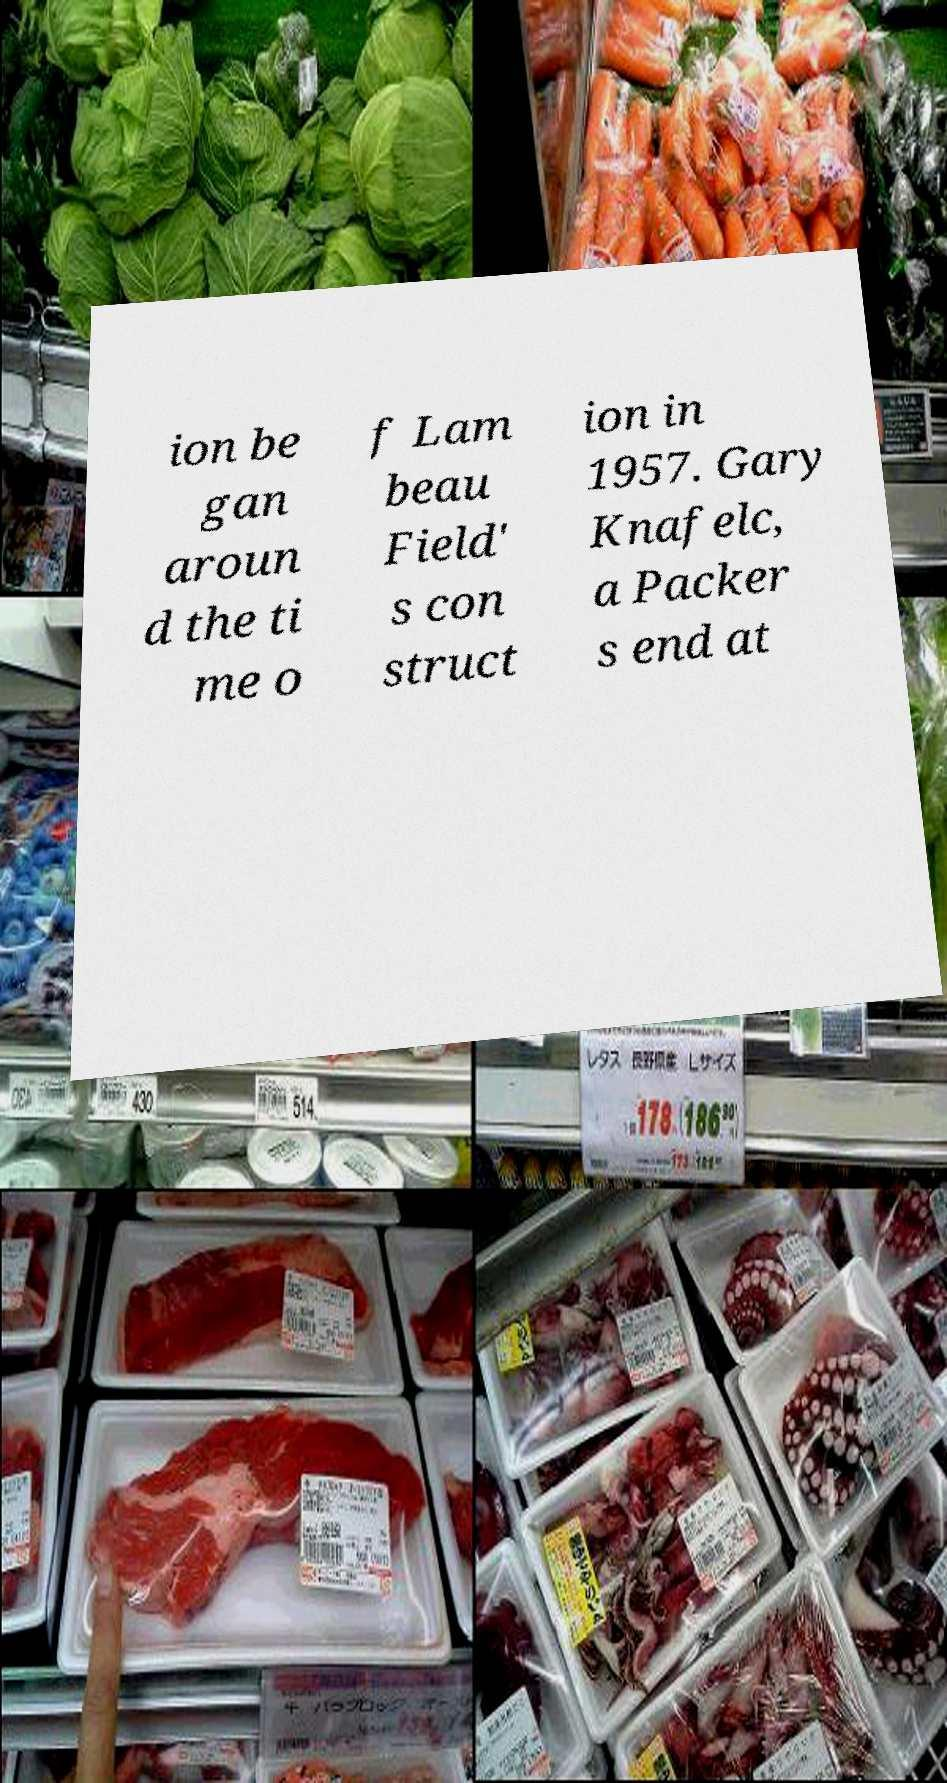I need the written content from this picture converted into text. Can you do that? ion be gan aroun d the ti me o f Lam beau Field' s con struct ion in 1957. Gary Knafelc, a Packer s end at 